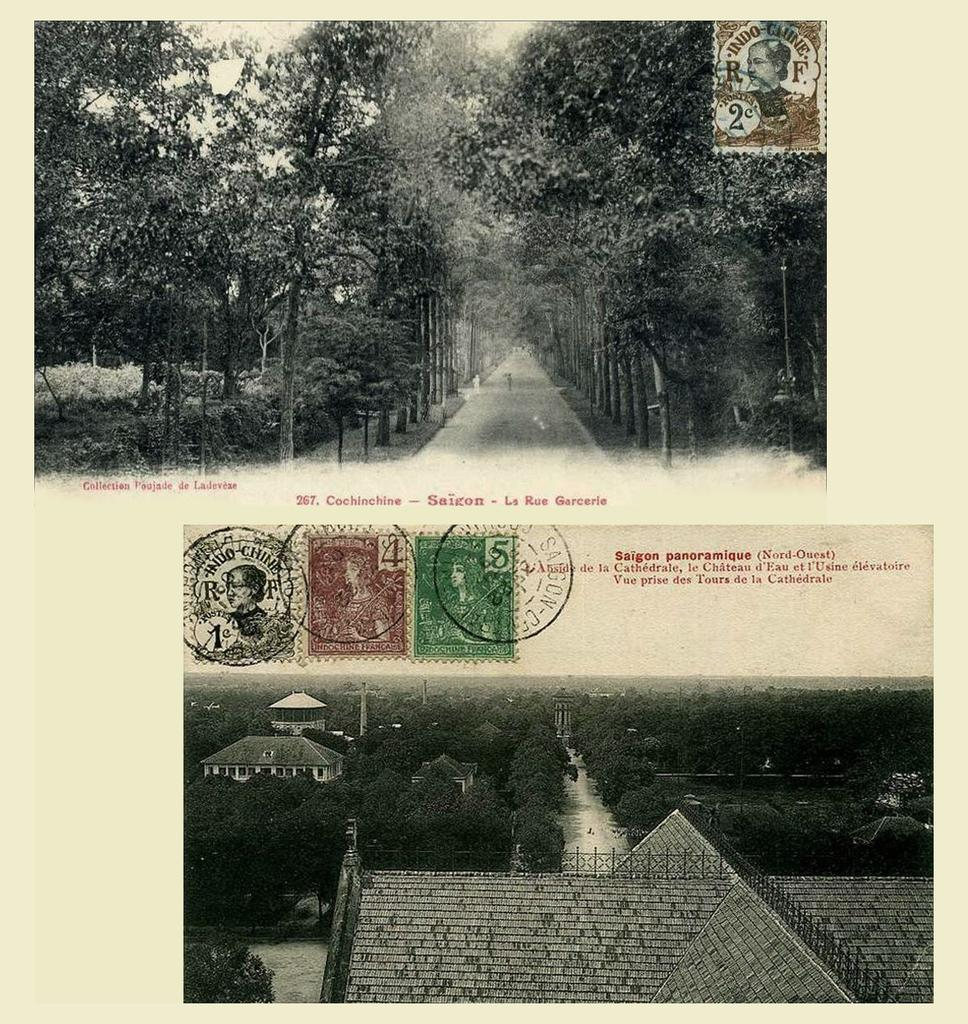How many photos are in the image? There are two photos in the image. What can be seen on the photos? The photos have postage stamps, numbers, and words on them. What is the photos placed on? The photos are on a paper. Can you tell me how many chess pieces are on the paper with the photos? There is no mention of chess pieces in the image, so it is not possible to determine their presence or quantity. 